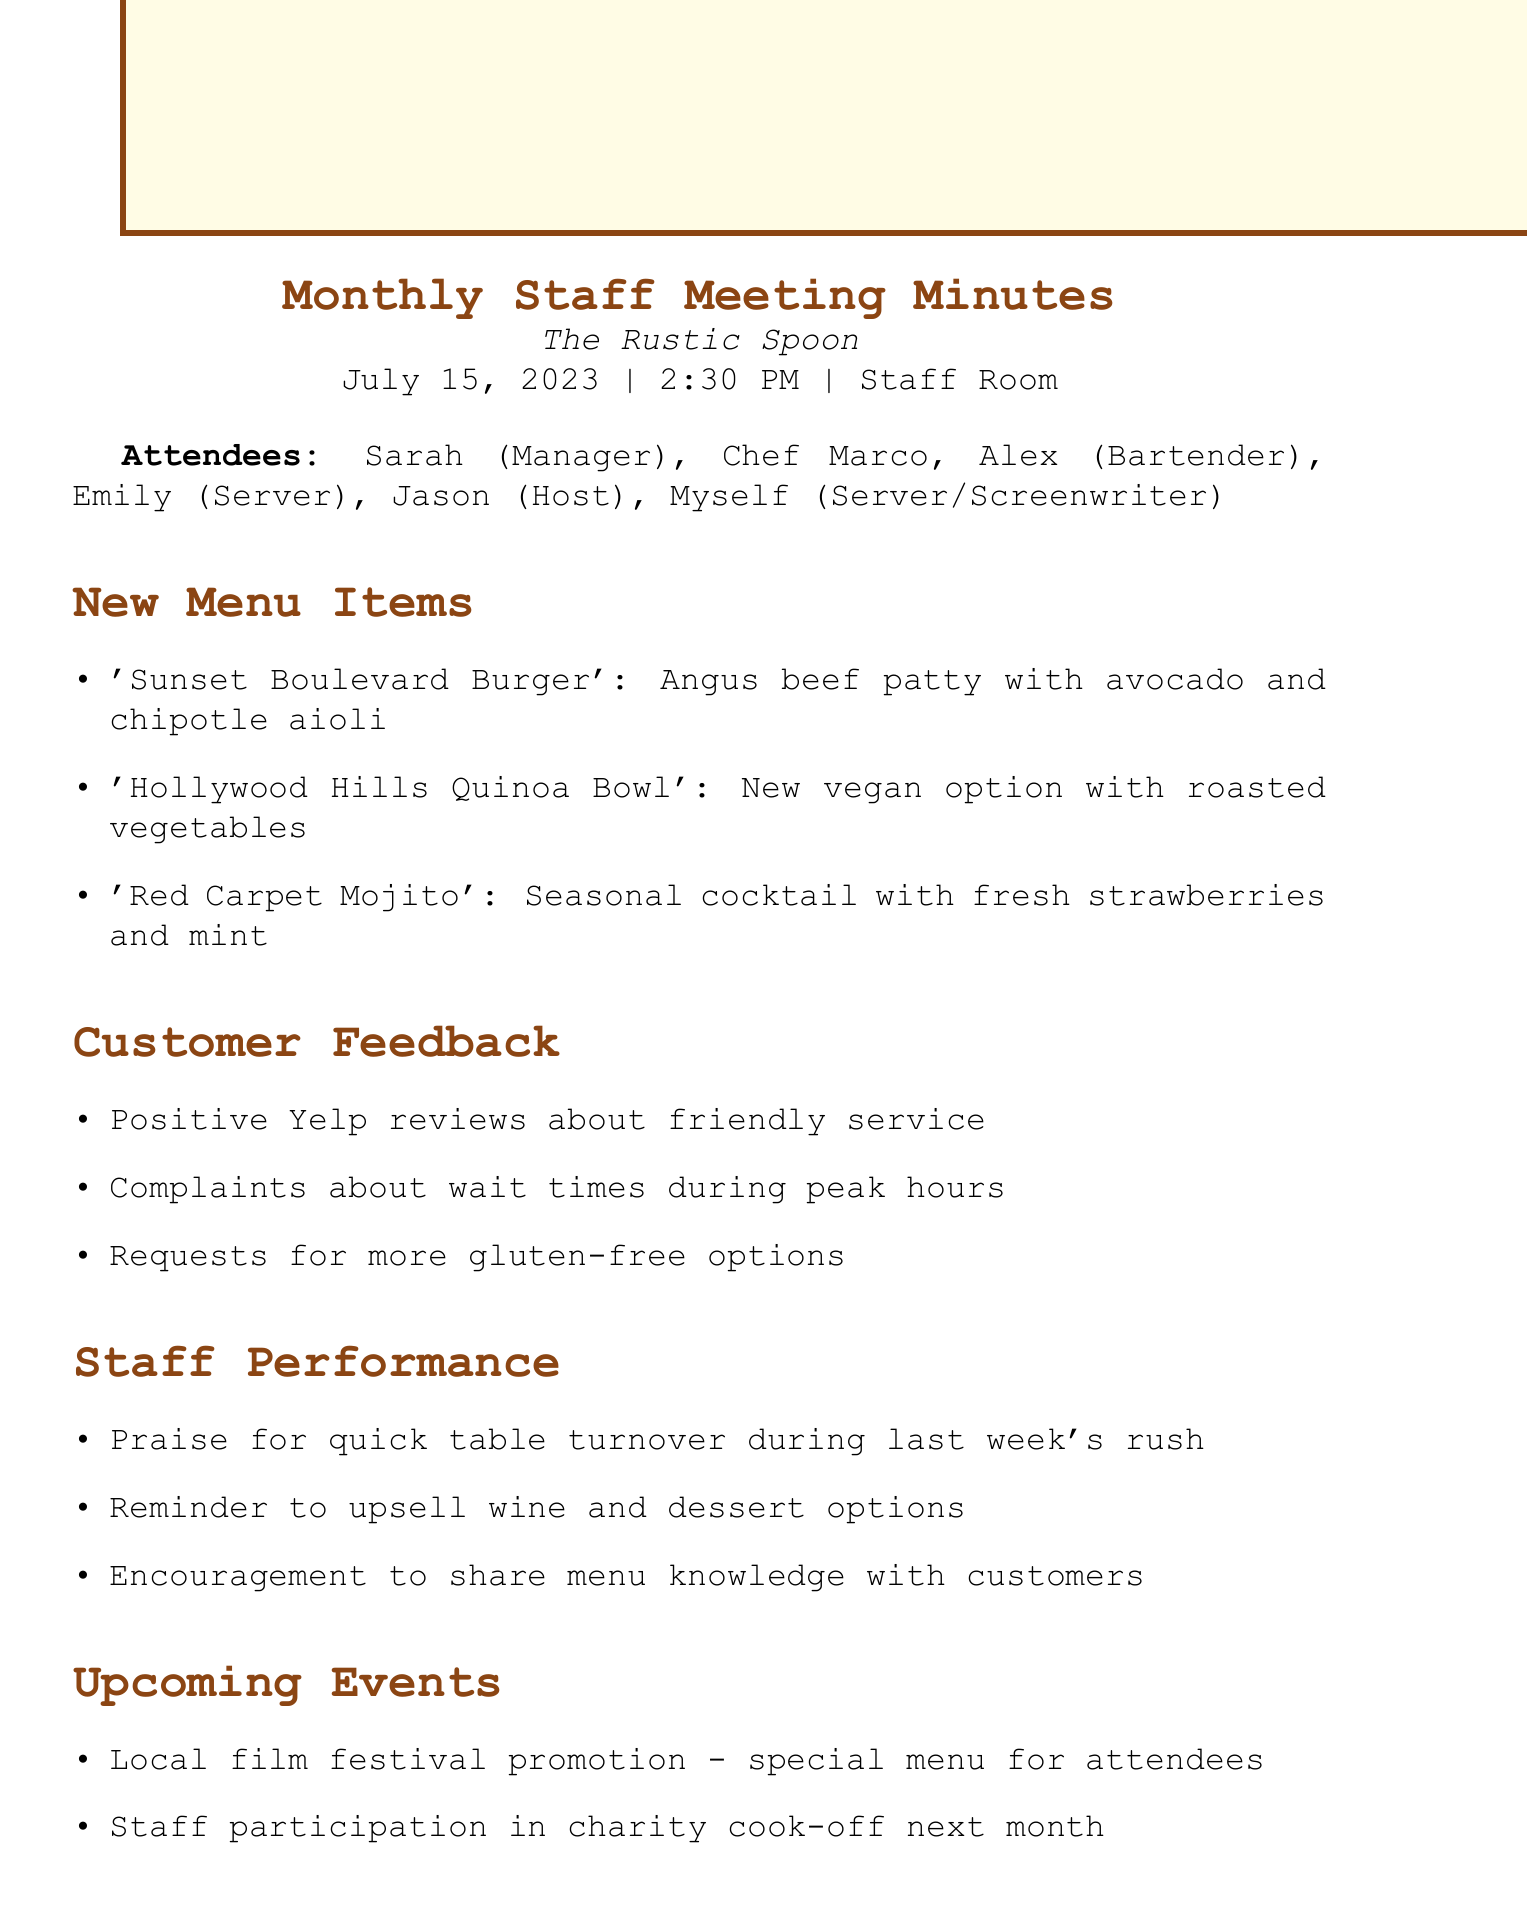What is the date of the meeting? The meeting is scheduled for July 15, 2023, as stated in the document.
Answer: July 15, 2023 Who proposed the 'Sunset Boulevard Burger'? The menu item 'Sunset Boulevard Burger' is introduced within the New Menu Items section, implying it was Chef Marco as the main contributor.
Answer: Chef Marco What are the two types of customer feedback mentioned? The document lists positive reviews and complaints, which cover two categories of feedback provided by customers.
Answer: Positive reviews and complaints When is the next meeting scheduled? The next meeting is noted in the document with a specific date and time stated at the end.
Answer: August 12, 2023 How many action items were there? There are three action items mentioned in the Action Items section of the document, detailing specific tasks to be completed.
Answer: Three 